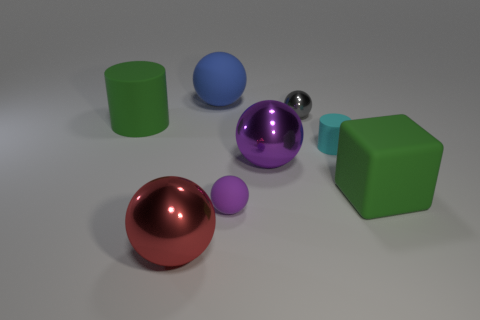The large sphere that is in front of the big green object that is on the right side of the small purple rubber sphere is what color?
Your answer should be compact. Red. How many cylinders are both on the left side of the tiny cylinder and in front of the green rubber cylinder?
Offer a terse response. 0. How many small cyan matte objects are the same shape as the purple metal object?
Offer a terse response. 0. Are the big red thing and the small purple sphere made of the same material?
Your answer should be very brief. No. There is a large green matte thing that is right of the tiny object that is in front of the green block; what shape is it?
Keep it short and to the point. Cube. What number of large shiny balls are on the right side of the small cyan thing that is behind the small purple sphere?
Your answer should be very brief. 0. What is the large object that is to the right of the big rubber sphere and left of the small gray object made of?
Give a very brief answer. Metal. There is a metallic object that is the same size as the cyan cylinder; what is its shape?
Your answer should be compact. Sphere. What is the color of the thing in front of the matte ball in front of the tiny sphere behind the tiny cylinder?
Keep it short and to the point. Red. What number of objects are metallic spheres that are in front of the gray shiny ball or blocks?
Make the answer very short. 3. 